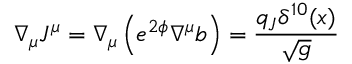Convert formula to latex. <formula><loc_0><loc_0><loc_500><loc_500>\nabla _ { \mu } J ^ { \mu } = \nabla _ { \mu } \left ( e ^ { 2 \phi } \nabla ^ { \mu } b \right ) = \frac { q _ { J } \delta ^ { 1 0 } ( x ) } { \sqrt { g } }</formula> 